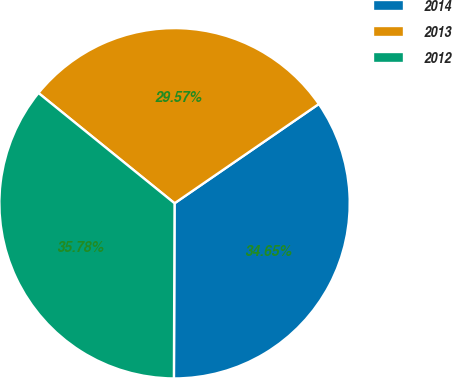Convert chart to OTSL. <chart><loc_0><loc_0><loc_500><loc_500><pie_chart><fcel>2014<fcel>2013<fcel>2012<nl><fcel>34.65%<fcel>29.57%<fcel>35.78%<nl></chart> 